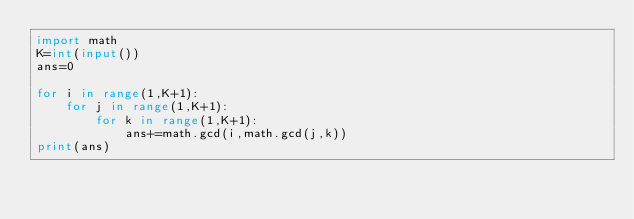Convert code to text. <code><loc_0><loc_0><loc_500><loc_500><_Python_>import math
K=int(input())
ans=0

for i in range(1,K+1):
    for j in range(1,K+1):
        for k in range(1,K+1):
            ans+=math.gcd(i,math.gcd(j,k))
print(ans)</code> 